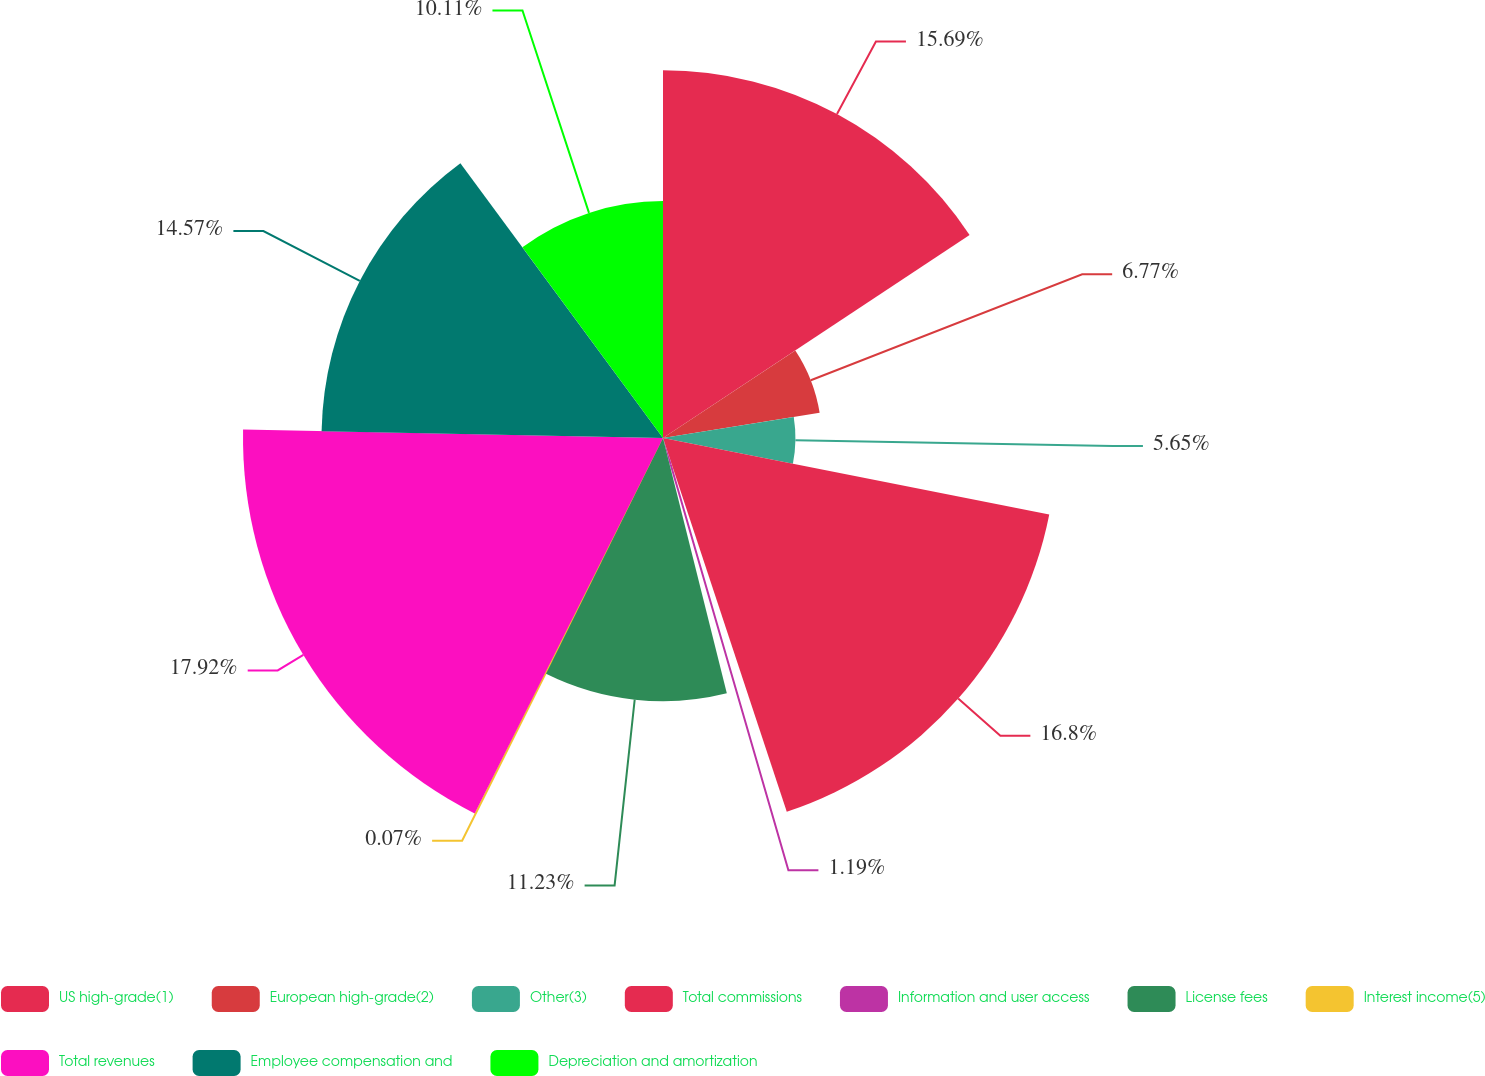Convert chart. <chart><loc_0><loc_0><loc_500><loc_500><pie_chart><fcel>US high-grade(1)<fcel>European high-grade(2)<fcel>Other(3)<fcel>Total commissions<fcel>Information and user access<fcel>License fees<fcel>Interest income(5)<fcel>Total revenues<fcel>Employee compensation and<fcel>Depreciation and amortization<nl><fcel>15.69%<fcel>6.77%<fcel>5.65%<fcel>16.8%<fcel>1.19%<fcel>11.23%<fcel>0.07%<fcel>17.92%<fcel>14.57%<fcel>10.11%<nl></chart> 